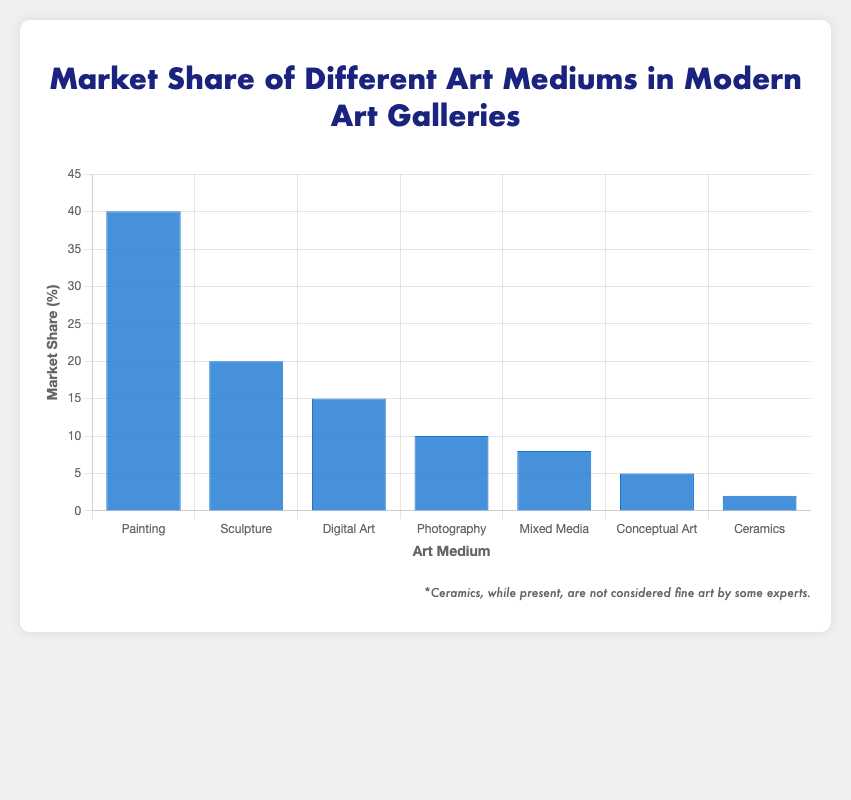Which medium has the highest market share? Observing the heights of the bars in the chart, the bar representing "Painting" is the tallest, indicating it has the highest market share.
Answer: Painting Which medium has the smallest market share? Checking the heights of the bars, the one representing "Ceramics" is the shortest, showing it has the smallest market share.
Answer: Ceramics What is the combined market share of Digital Art and Mixed Media? To find the combined market share, add the market shares of Digital Art (15%) and Mixed Media (8%). 15 + 8 = 23.
Answer: 23% How much more market share does Painting have compared to Sculpture? Subtract the market share of Sculpture (20%) from the market share of Painting (40%). 40 - 20 = 20
Answer: 20% What is the average market share percentage of Sculpture, Digital Art, and Photography? First add the market shares: Sculpture (20%) + Digital Art (15%) + Photography (10%) = 45%. Then divide by the number of mediums: 45 / 3 = 15.
Answer: 15% Which medium has double the market share of Ceramics? Ceramics has a market share of 2%. The medium with double this share is the one with 4%, but there is no such medium. Hence, no art medium has exactly double Ceramics' share.
Answer: None How does the market share of Mixed Media compare to Conceptual Art? The market share of Mixed Media is 8%, while that of Conceptual Art is 5%. Mixed Media has a higher market share compared to Conceptual Art.
Answer: Mixed Media If Photography and Ceramics were grouped together, what would their market share percentage be? To find the combined market share, sum the percentages of Photography (10%) and Ceramics (2%). 10 + 2 = 12.
Answer: 12% What is the median market share percentage of all art mediums shown? List the market shares in ascending order: 2%, 5%, 8%, 10%, 15%, 20%, 40%. The median value is the middle value in this list, which is 10%.
Answer: 10% 